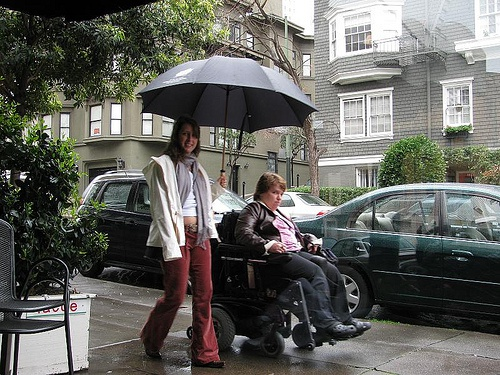Describe the objects in this image and their specific colors. I can see car in black, gray, darkgray, and lightgray tones, people in black, gray, lightgray, and maroon tones, umbrella in black, darkgray, and lightgray tones, chair in black, gray, darkgray, and lightgray tones, and people in black, gray, lavender, and darkgray tones in this image. 